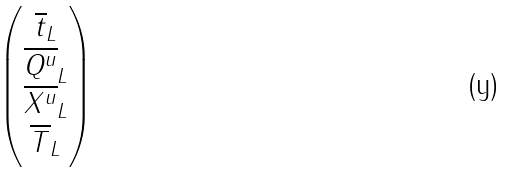<formula> <loc_0><loc_0><loc_500><loc_500>\begin{pmatrix} \overline { t } _ { L } \\ \overline { Q ^ { u } } _ { L } \\ \overline { X ^ { u } } _ { L } \\ \overline { T } _ { L } \end{pmatrix}</formula> 